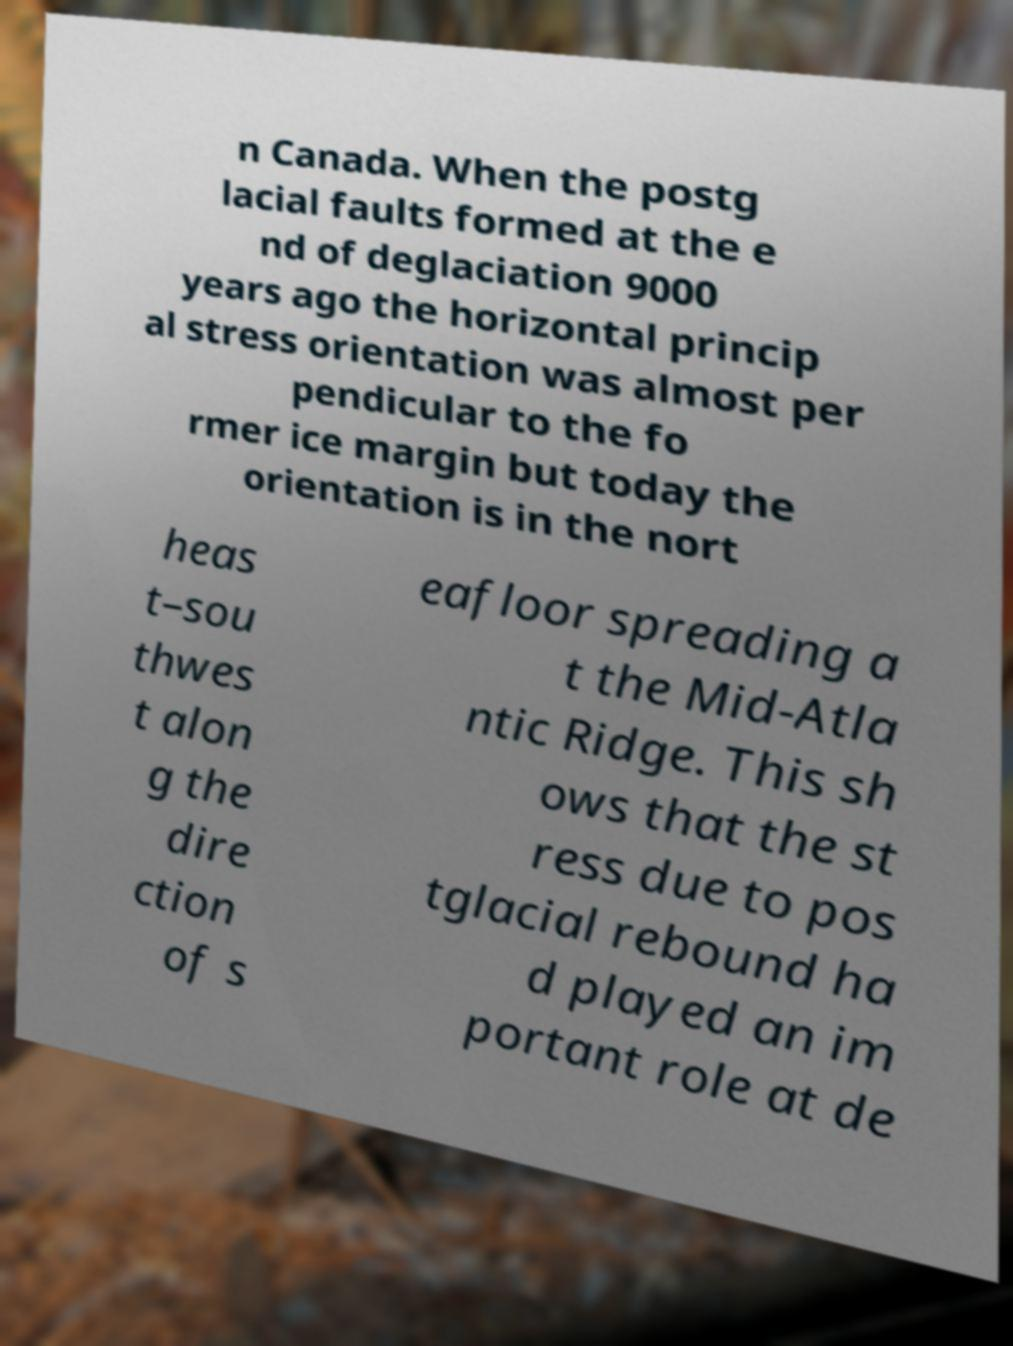Could you assist in decoding the text presented in this image and type it out clearly? n Canada. When the postg lacial faults formed at the e nd of deglaciation 9000 years ago the horizontal princip al stress orientation was almost per pendicular to the fo rmer ice margin but today the orientation is in the nort heas t–sou thwes t alon g the dire ction of s eafloor spreading a t the Mid-Atla ntic Ridge. This sh ows that the st ress due to pos tglacial rebound ha d played an im portant role at de 